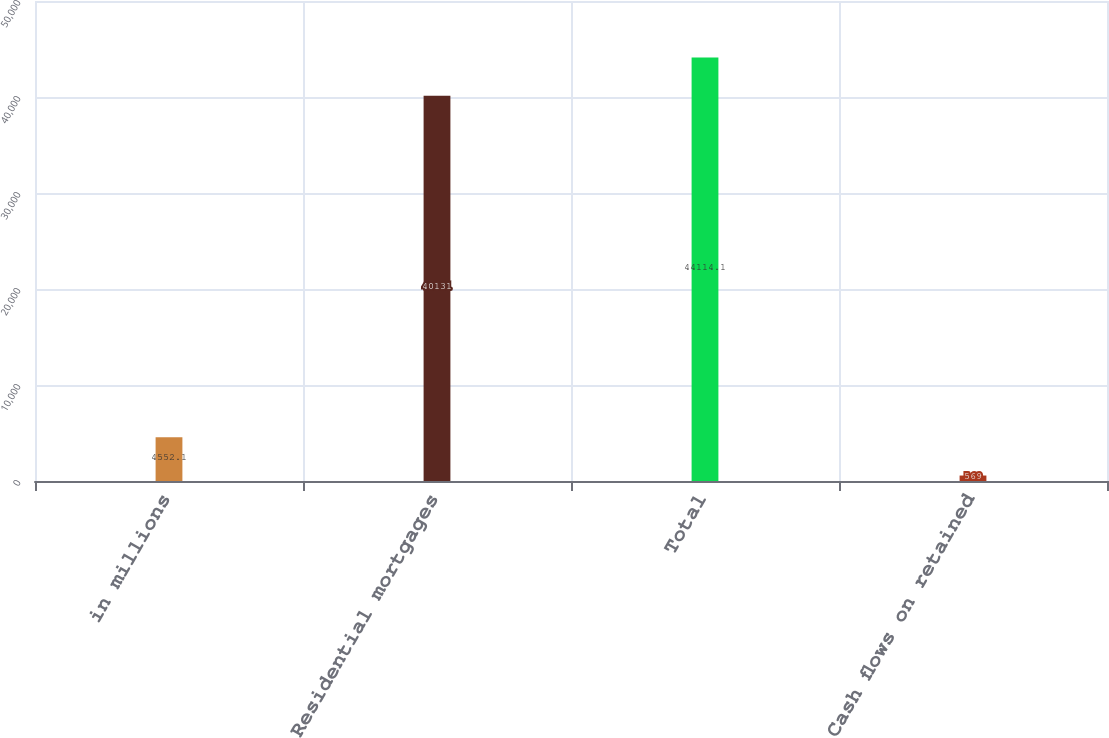<chart> <loc_0><loc_0><loc_500><loc_500><bar_chart><fcel>in millions<fcel>Residential mortgages<fcel>Total<fcel>Cash flows on retained<nl><fcel>4552.1<fcel>40131<fcel>44114.1<fcel>569<nl></chart> 